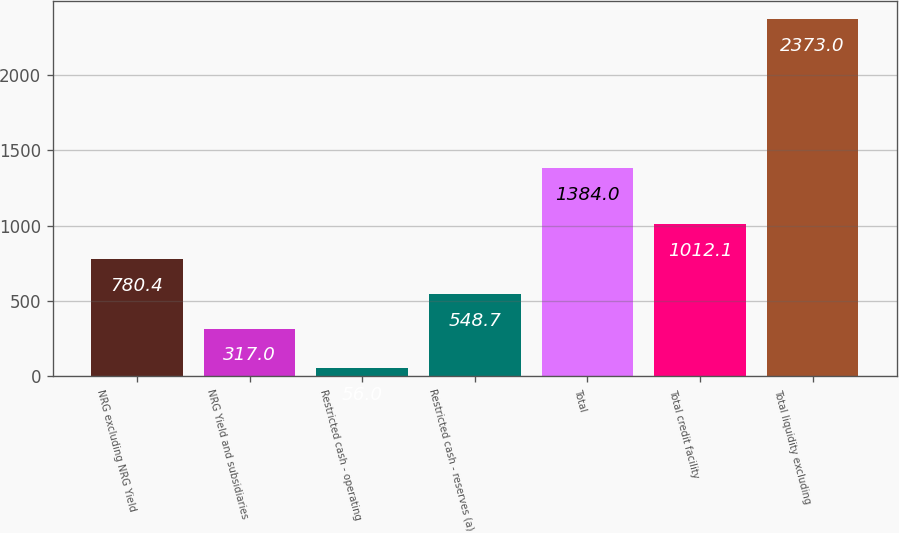Convert chart to OTSL. <chart><loc_0><loc_0><loc_500><loc_500><bar_chart><fcel>NRG excluding NRG Yield<fcel>NRG Yield and subsidiaries<fcel>Restricted cash - operating<fcel>Restricted cash - reserves (a)<fcel>Total<fcel>Total credit facility<fcel>Total liquidity excluding<nl><fcel>780.4<fcel>317<fcel>56<fcel>548.7<fcel>1384<fcel>1012.1<fcel>2373<nl></chart> 